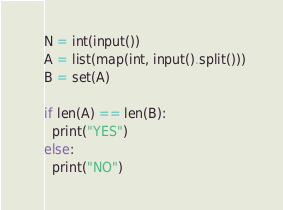Convert code to text. <code><loc_0><loc_0><loc_500><loc_500><_Python_>N = int(input())
A = list(map(int, input().split())) 
B = set(A)

if len(A) == len(B):
  print("YES")
else:
  print("NO")</code> 